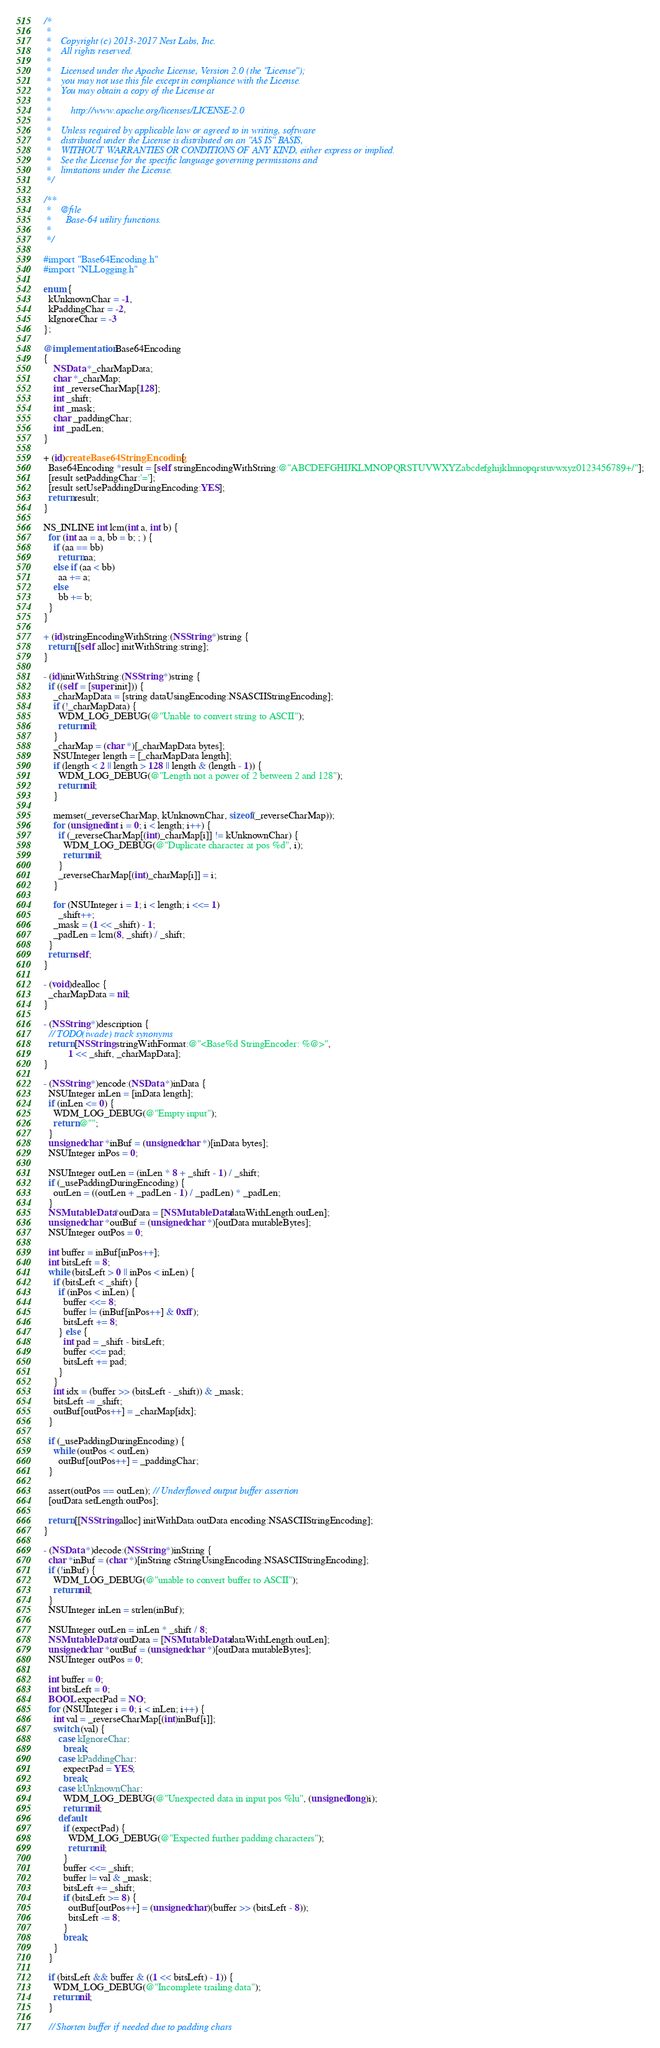Convert code to text. <code><loc_0><loc_0><loc_500><loc_500><_ObjectiveC_>/*
 *
 *    Copyright (c) 2013-2017 Nest Labs, Inc.
 *    All rights reserved.
 *
 *    Licensed under the Apache License, Version 2.0 (the "License");
 *    you may not use this file except in compliance with the License.
 *    You may obtain a copy of the License at
 *
 *        http://www.apache.org/licenses/LICENSE-2.0
 *
 *    Unless required by applicable law or agreed to in writing, software
 *    distributed under the License is distributed on an "AS IS" BASIS,
 *    WITHOUT WARRANTIES OR CONDITIONS OF ANY KIND, either express or implied.
 *    See the License for the specific language governing permissions and
 *    limitations under the License.
 */

/**
 *    @file
 *      Base-64 utility functions.
 *
 */

#import "Base64Encoding.h"
#import "NLLogging.h"

enum {
  kUnknownChar = -1,
  kPaddingChar = -2,
  kIgnoreChar = -3
};

@implementation Base64Encoding
{
    NSData *_charMapData;
    char *_charMap;
    int _reverseCharMap[128];
    int _shift;
    int _mask;
    char _paddingChar;
    int _padLen;
}

+ (id)createBase64StringEncoding {
  Base64Encoding *result = [self stringEncodingWithString:@"ABCDEFGHIJKLMNOPQRSTUVWXYZabcdefghijklmnopqrstuvwxyz0123456789+/"];
  [result setPaddingChar:'='];
  [result setUsePaddingDuringEncoding:YES];
  return result;
}

NS_INLINE int lcm(int a, int b) {
  for (int aa = a, bb = b; ; ) {
    if (aa == bb)
      return aa;
    else if (aa < bb)
      aa += a;
    else
      bb += b;
  }
}

+ (id)stringEncodingWithString:(NSString *)string {
  return [[self alloc] initWithString:string];
}

- (id)initWithString:(NSString *)string {
  if ((self = [super init])) {
    _charMapData = [string dataUsingEncoding:NSASCIIStringEncoding];
    if (!_charMapData) {
      WDM_LOG_DEBUG(@"Unable to convert string to ASCII");
      return nil;
    }
    _charMap = (char *)[_charMapData bytes];
    NSUInteger length = [_charMapData length];
    if (length < 2 || length > 128 || length & (length - 1)) {
      WDM_LOG_DEBUG(@"Length not a power of 2 between 2 and 128");
      return nil;
    }

    memset(_reverseCharMap, kUnknownChar, sizeof(_reverseCharMap));
    for (unsigned int i = 0; i < length; i++) {
      if (_reverseCharMap[(int)_charMap[i]] != kUnknownChar) {
        WDM_LOG_DEBUG(@"Duplicate character at pos %d", i);
        return nil;
      }
      _reverseCharMap[(int)_charMap[i]] = i;
    }

    for (NSUInteger i = 1; i < length; i <<= 1)
      _shift++;
    _mask = (1 << _shift) - 1;
    _padLen = lcm(8, _shift) / _shift;
  }
  return self;
}

- (void)dealloc {
  _charMapData = nil;
}

- (NSString *)description {
  // TODO(iwade) track synonyms
  return [NSString stringWithFormat:@"<Base%d StringEncoder: %@>",
          1 << _shift, _charMapData];
}

- (NSString *)encode:(NSData *)inData {
  NSUInteger inLen = [inData length];
  if (inLen <= 0) {
    WDM_LOG_DEBUG(@"Empty input");
    return @"";
  }
  unsigned char *inBuf = (unsigned char *)[inData bytes];
  NSUInteger inPos = 0;

  NSUInteger outLen = (inLen * 8 + _shift - 1) / _shift;
  if (_usePaddingDuringEncoding) {
    outLen = ((outLen + _padLen - 1) / _padLen) * _padLen;
  }
  NSMutableData *outData = [NSMutableData dataWithLength:outLen];
  unsigned char *outBuf = (unsigned char *)[outData mutableBytes];
  NSUInteger outPos = 0;

  int buffer = inBuf[inPos++];
  int bitsLeft = 8;
  while (bitsLeft > 0 || inPos < inLen) {
    if (bitsLeft < _shift) {
      if (inPos < inLen) {
        buffer <<= 8;
        buffer |= (inBuf[inPos++] & 0xff);
        bitsLeft += 8;
      } else {
        int pad = _shift - bitsLeft;
        buffer <<= pad;
        bitsLeft += pad;
      }
    }
    int idx = (buffer >> (bitsLeft - _shift)) & _mask;
    bitsLeft -= _shift;
    outBuf[outPos++] = _charMap[idx];
  }

  if (_usePaddingDuringEncoding) {
    while (outPos < outLen)
      outBuf[outPos++] = _paddingChar;
  }

  assert(outPos == outLen); // Underflowed output buffer assertion
  [outData setLength:outPos];

  return [[NSString alloc] initWithData:outData encoding:NSASCIIStringEncoding];
}

- (NSData *)decode:(NSString *)inString {
  char *inBuf = (char *)[inString cStringUsingEncoding:NSASCIIStringEncoding];
  if (!inBuf) {
    WDM_LOG_DEBUG(@"unable to convert buffer to ASCII");
    return nil;
  }
  NSUInteger inLen = strlen(inBuf);

  NSUInteger outLen = inLen * _shift / 8;
  NSMutableData *outData = [NSMutableData dataWithLength:outLen];
  unsigned char *outBuf = (unsigned char *)[outData mutableBytes];
  NSUInteger outPos = 0;

  int buffer = 0;
  int bitsLeft = 0;
  BOOL expectPad = NO;
  for (NSUInteger i = 0; i < inLen; i++) {
    int val = _reverseCharMap[(int)inBuf[i]];
    switch (val) {
      case kIgnoreChar:
        break;
      case kPaddingChar:
        expectPad = YES;
        break;
      case kUnknownChar:
        WDM_LOG_DEBUG(@"Unexpected data in input pos %lu", (unsigned long)i);
        return nil;
      default:
        if (expectPad) {
          WDM_LOG_DEBUG(@"Expected further padding characters");
          return nil;
        }
        buffer <<= _shift;
        buffer |= val & _mask;
        bitsLeft += _shift;
        if (bitsLeft >= 8) {
          outBuf[outPos++] = (unsigned char)(buffer >> (bitsLeft - 8));
          bitsLeft -= 8;
        }
        break;
    }
  }

  if (bitsLeft && buffer & ((1 << bitsLeft) - 1)) {
    WDM_LOG_DEBUG(@"Incomplete trailing data");
    return nil;
  }

  // Shorten buffer if needed due to padding chars</code> 